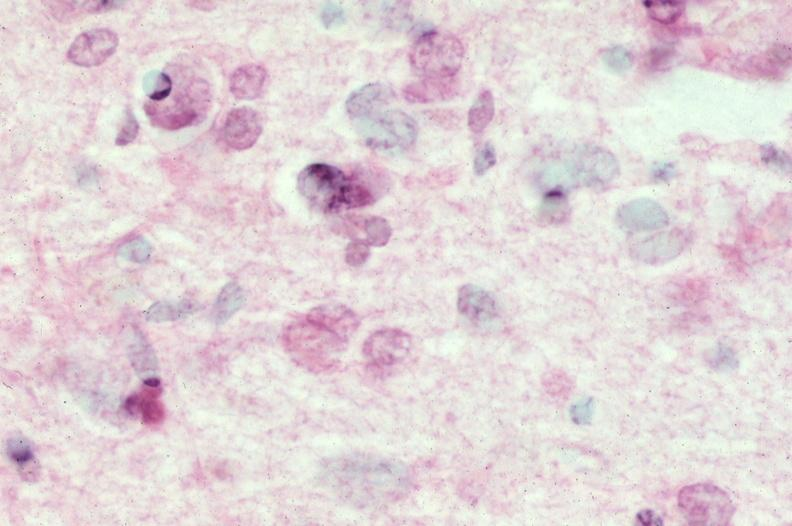what is present?
Answer the question using a single word or phrase. Nervous 